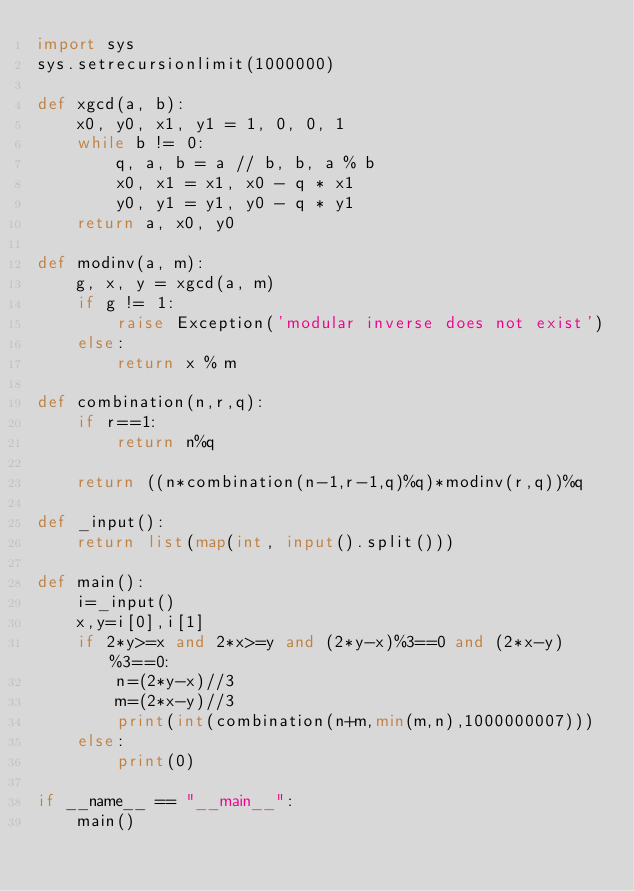<code> <loc_0><loc_0><loc_500><loc_500><_Python_>import sys
sys.setrecursionlimit(1000000)
 
def xgcd(a, b):
    x0, y0, x1, y1 = 1, 0, 0, 1
    while b != 0:
        q, a, b = a // b, b, a % b
        x0, x1 = x1, x0 - q * x1
        y0, y1 = y1, y0 - q * y1
    return a, x0, y0
 
def modinv(a, m):
    g, x, y = xgcd(a, m)
    if g != 1:
        raise Exception('modular inverse does not exist')
    else:
        return x % m
 
def combination(n,r,q):
    if r==1:
        return n%q
 
    return ((n*combination(n-1,r-1,q)%q)*modinv(r,q))%q
 
def _input():
    return list(map(int, input().split()))
 
def main():
    i=_input()
    x,y=i[0],i[1]
    if 2*y>=x and 2*x>=y and (2*y-x)%3==0 and (2*x-y)%3==0:
        n=(2*y-x)//3
        m=(2*x-y)//3
        print(int(combination(n+m,min(m,n),1000000007)))
    else:
        print(0)
 
if __name__ == "__main__":
    main()
</code> 